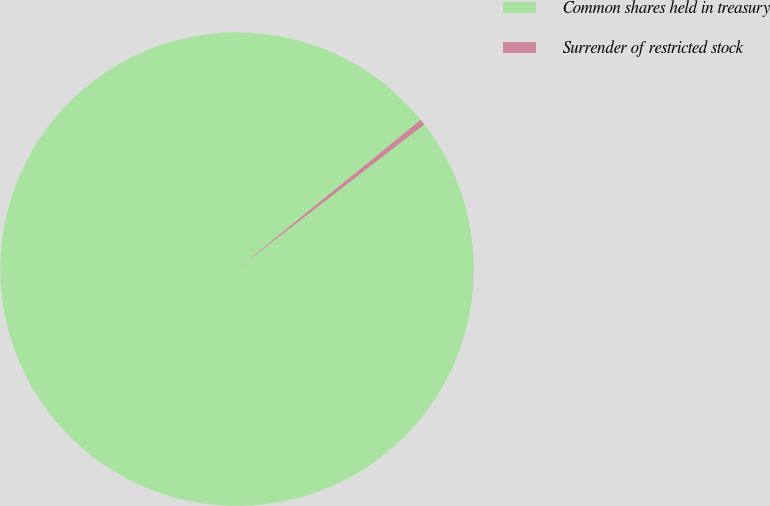Convert chart. <chart><loc_0><loc_0><loc_500><loc_500><pie_chart><fcel>Common shares held in treasury<fcel>Surrender of restricted stock<nl><fcel>99.6%<fcel>0.4%<nl></chart> 